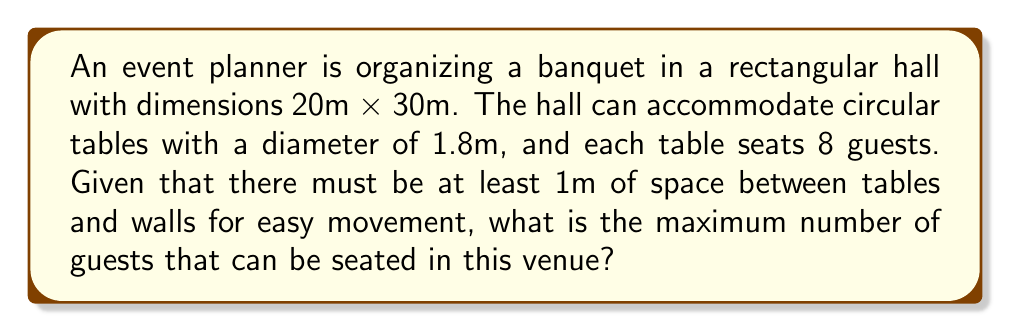Can you solve this math problem? Let's approach this problem step-by-step:

1) First, we need to calculate the effective area where tables can be placed:
   - Length: $20m - 2m = 18m$ (subtracting 1m from each side)
   - Width: $30m - 2m = 28m$ (subtracting 1m from each side)
   - Effective area: $18m \times 28m = 504m^2$

2) Now, we need to determine the area occupied by each table, including the required space around it:
   - Table diameter: 1.8m
   - Required space around table: 1m on each side
   - Total diameter of space needed: $1.8m + 2m = 3.8m$
   - Area per table: $\pi r^2 = \pi (1.9m)^2 \approx 11.34m^2$

3) To find the number of tables that can fit, we divide the effective area by the area per table:
   $$ \text{Number of tables} = \frac{504m^2}{11.34m^2} \approx 44.44 $$

4) Since we can't have a fraction of a table, we round down to 44 tables.

5) Each table seats 8 guests, so the total number of guests is:
   $$ \text{Total guests} = 44 \times 8 = 352 $$

Therefore, the maximum number of guests that can be seated is 352.
Answer: 352 guests 